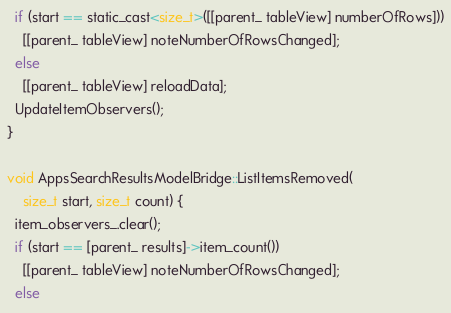Convert code to text. <code><loc_0><loc_0><loc_500><loc_500><_ObjectiveC_>  if (start == static_cast<size_t>([[parent_ tableView] numberOfRows]))
    [[parent_ tableView] noteNumberOfRowsChanged];
  else
    [[parent_ tableView] reloadData];
  UpdateItemObservers();
}

void AppsSearchResultsModelBridge::ListItemsRemoved(
    size_t start, size_t count) {
  item_observers_.clear();
  if (start == [parent_ results]->item_count())
    [[parent_ tableView] noteNumberOfRowsChanged];
  else</code> 